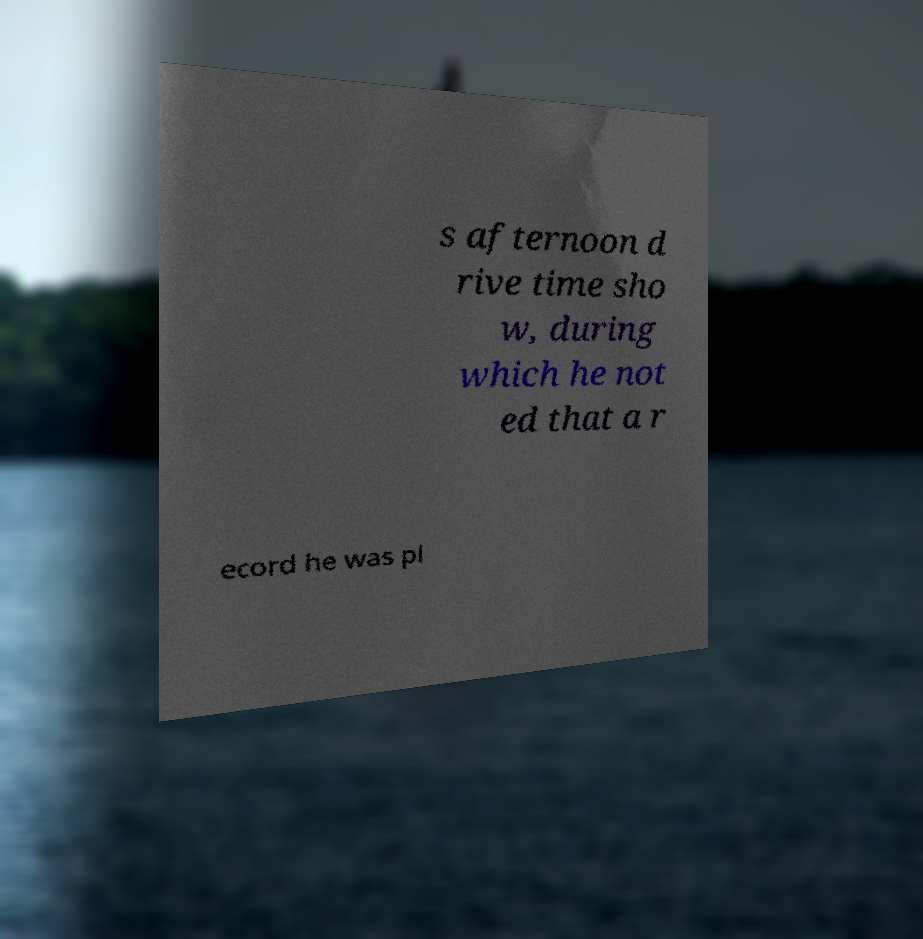Can you accurately transcribe the text from the provided image for me? s afternoon d rive time sho w, during which he not ed that a r ecord he was pl 